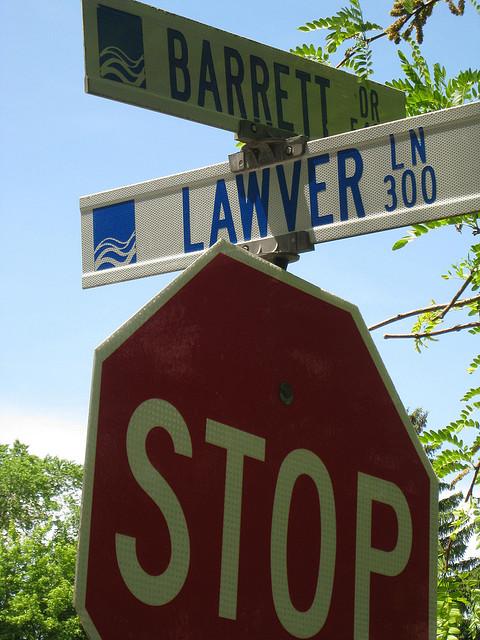What streets go through this intersection?
Answer briefly. Barrett and lawver. What are the two street names?
Quick response, please. Barrett and lawver. Is the sign an octagon?
Be succinct. Yes. What should a driver do when they approach this sign?
Keep it brief. Stop. 